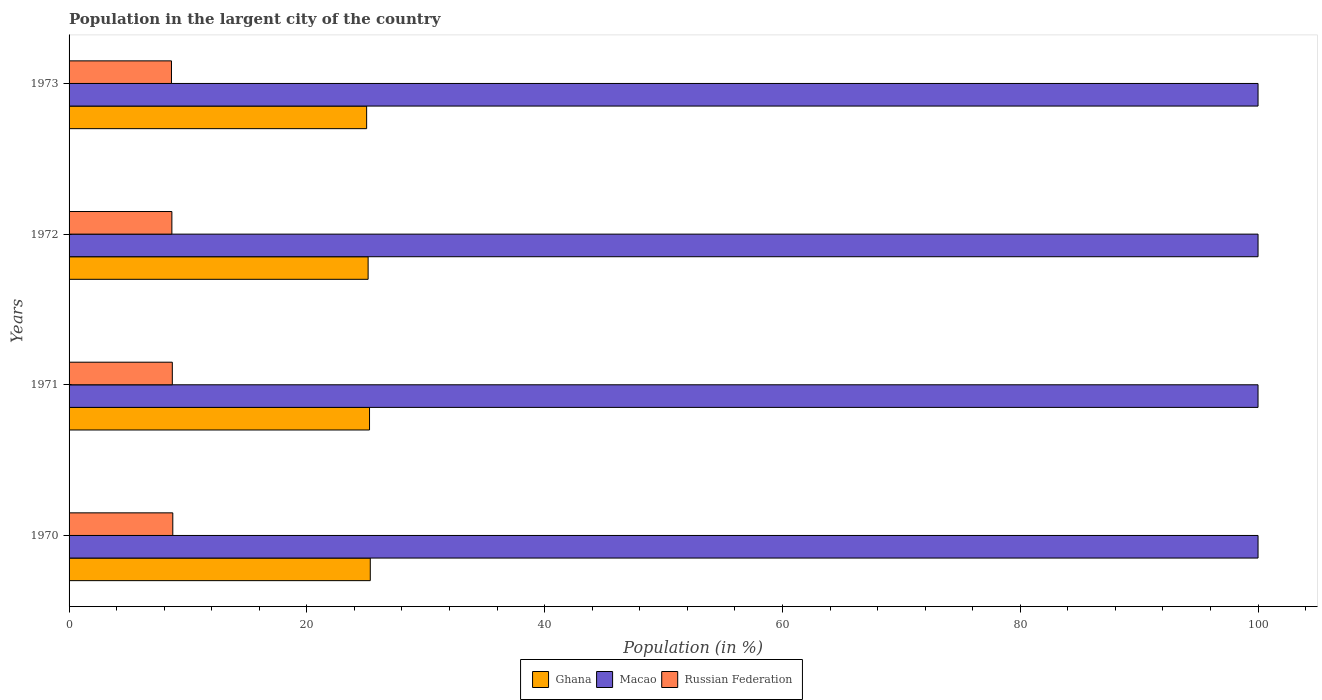How many groups of bars are there?
Give a very brief answer. 4. Are the number of bars per tick equal to the number of legend labels?
Give a very brief answer. Yes. Are the number of bars on each tick of the Y-axis equal?
Your answer should be very brief. Yes. How many bars are there on the 3rd tick from the top?
Your answer should be very brief. 3. How many bars are there on the 3rd tick from the bottom?
Keep it short and to the point. 3. In how many cases, is the number of bars for a given year not equal to the number of legend labels?
Your answer should be compact. 0. What is the percentage of population in the largent city in Russian Federation in 1971?
Your answer should be very brief. 8.68. Across all years, what is the maximum percentage of population in the largent city in Russian Federation?
Provide a succinct answer. 8.72. Across all years, what is the minimum percentage of population in the largent city in Russian Federation?
Your response must be concise. 8.61. In which year was the percentage of population in the largent city in Russian Federation maximum?
Provide a succinct answer. 1970. In which year was the percentage of population in the largent city in Macao minimum?
Make the answer very short. 1971. What is the total percentage of population in the largent city in Macao in the graph?
Your answer should be compact. 400. What is the difference between the percentage of population in the largent city in Macao in 1970 and that in 1973?
Offer a very short reply. 0. What is the difference between the percentage of population in the largent city in Ghana in 1971 and the percentage of population in the largent city in Macao in 1972?
Give a very brief answer. -74.73. What is the average percentage of population in the largent city in Russian Federation per year?
Provide a short and direct response. 8.67. In the year 1971, what is the difference between the percentage of population in the largent city in Ghana and percentage of population in the largent city in Russian Federation?
Give a very brief answer. 16.59. What is the ratio of the percentage of population in the largent city in Ghana in 1971 to that in 1973?
Your response must be concise. 1.01. Is the difference between the percentage of population in the largent city in Ghana in 1970 and 1973 greater than the difference between the percentage of population in the largent city in Russian Federation in 1970 and 1973?
Provide a succinct answer. Yes. What is the difference between the highest and the second highest percentage of population in the largent city in Ghana?
Your answer should be very brief. 0.06. What is the difference between the highest and the lowest percentage of population in the largent city in Macao?
Make the answer very short. 0. In how many years, is the percentage of population in the largent city in Macao greater than the average percentage of population in the largent city in Macao taken over all years?
Provide a succinct answer. 3. What does the 3rd bar from the top in 1970 represents?
Make the answer very short. Ghana. What does the 3rd bar from the bottom in 1973 represents?
Provide a short and direct response. Russian Federation. What is the difference between two consecutive major ticks on the X-axis?
Offer a terse response. 20. Are the values on the major ticks of X-axis written in scientific E-notation?
Your answer should be very brief. No. Does the graph contain any zero values?
Your answer should be very brief. No. Does the graph contain grids?
Your response must be concise. No. How many legend labels are there?
Ensure brevity in your answer.  3. How are the legend labels stacked?
Make the answer very short. Horizontal. What is the title of the graph?
Your answer should be very brief. Population in the largent city of the country. Does "Tajikistan" appear as one of the legend labels in the graph?
Make the answer very short. No. What is the label or title of the X-axis?
Ensure brevity in your answer.  Population (in %). What is the Population (in %) in Ghana in 1970?
Give a very brief answer. 25.33. What is the Population (in %) of Macao in 1970?
Give a very brief answer. 100. What is the Population (in %) of Russian Federation in 1970?
Ensure brevity in your answer.  8.72. What is the Population (in %) of Ghana in 1971?
Provide a succinct answer. 25.27. What is the Population (in %) in Macao in 1971?
Provide a short and direct response. 100. What is the Population (in %) of Russian Federation in 1971?
Make the answer very short. 8.68. What is the Population (in %) of Ghana in 1972?
Give a very brief answer. 25.15. What is the Population (in %) in Russian Federation in 1972?
Offer a very short reply. 8.65. What is the Population (in %) in Ghana in 1973?
Keep it short and to the point. 25.03. What is the Population (in %) in Russian Federation in 1973?
Your answer should be compact. 8.61. Across all years, what is the maximum Population (in %) of Ghana?
Offer a very short reply. 25.33. Across all years, what is the maximum Population (in %) in Macao?
Your answer should be compact. 100. Across all years, what is the maximum Population (in %) in Russian Federation?
Your response must be concise. 8.72. Across all years, what is the minimum Population (in %) in Ghana?
Provide a succinct answer. 25.03. Across all years, what is the minimum Population (in %) in Macao?
Ensure brevity in your answer.  100. Across all years, what is the minimum Population (in %) in Russian Federation?
Your answer should be very brief. 8.61. What is the total Population (in %) in Ghana in the graph?
Provide a succinct answer. 100.78. What is the total Population (in %) of Macao in the graph?
Keep it short and to the point. 400. What is the total Population (in %) in Russian Federation in the graph?
Give a very brief answer. 34.67. What is the difference between the Population (in %) of Ghana in 1970 and that in 1971?
Offer a very short reply. 0.06. What is the difference between the Population (in %) in Macao in 1970 and that in 1971?
Offer a terse response. 0. What is the difference between the Population (in %) in Russian Federation in 1970 and that in 1971?
Ensure brevity in your answer.  0.04. What is the difference between the Population (in %) of Ghana in 1970 and that in 1972?
Offer a terse response. 0.18. What is the difference between the Population (in %) in Macao in 1970 and that in 1972?
Keep it short and to the point. 0. What is the difference between the Population (in %) of Russian Federation in 1970 and that in 1972?
Your answer should be compact. 0.08. What is the difference between the Population (in %) of Ghana in 1970 and that in 1973?
Offer a terse response. 0.31. What is the difference between the Population (in %) of Macao in 1970 and that in 1973?
Your response must be concise. 0. What is the difference between the Population (in %) of Russian Federation in 1970 and that in 1973?
Provide a short and direct response. 0.11. What is the difference between the Population (in %) in Ghana in 1971 and that in 1972?
Offer a very short reply. 0.12. What is the difference between the Population (in %) of Macao in 1971 and that in 1972?
Your answer should be very brief. -0. What is the difference between the Population (in %) of Russian Federation in 1971 and that in 1972?
Offer a terse response. 0.04. What is the difference between the Population (in %) in Ghana in 1971 and that in 1973?
Make the answer very short. 0.24. What is the difference between the Population (in %) of Macao in 1971 and that in 1973?
Your answer should be very brief. -0. What is the difference between the Population (in %) in Russian Federation in 1971 and that in 1973?
Your response must be concise. 0.07. What is the difference between the Population (in %) of Ghana in 1972 and that in 1973?
Provide a succinct answer. 0.12. What is the difference between the Population (in %) in Macao in 1972 and that in 1973?
Give a very brief answer. 0. What is the difference between the Population (in %) in Russian Federation in 1972 and that in 1973?
Provide a short and direct response. 0.03. What is the difference between the Population (in %) of Ghana in 1970 and the Population (in %) of Macao in 1971?
Offer a very short reply. -74.67. What is the difference between the Population (in %) of Ghana in 1970 and the Population (in %) of Russian Federation in 1971?
Your response must be concise. 16.65. What is the difference between the Population (in %) of Macao in 1970 and the Population (in %) of Russian Federation in 1971?
Offer a very short reply. 91.32. What is the difference between the Population (in %) in Ghana in 1970 and the Population (in %) in Macao in 1972?
Your answer should be very brief. -74.67. What is the difference between the Population (in %) of Ghana in 1970 and the Population (in %) of Russian Federation in 1972?
Your answer should be compact. 16.69. What is the difference between the Population (in %) of Macao in 1970 and the Population (in %) of Russian Federation in 1972?
Offer a very short reply. 91.35. What is the difference between the Population (in %) of Ghana in 1970 and the Population (in %) of Macao in 1973?
Provide a short and direct response. -74.67. What is the difference between the Population (in %) of Ghana in 1970 and the Population (in %) of Russian Federation in 1973?
Provide a succinct answer. 16.72. What is the difference between the Population (in %) of Macao in 1970 and the Population (in %) of Russian Federation in 1973?
Keep it short and to the point. 91.39. What is the difference between the Population (in %) in Ghana in 1971 and the Population (in %) in Macao in 1972?
Offer a very short reply. -74.73. What is the difference between the Population (in %) in Ghana in 1971 and the Population (in %) in Russian Federation in 1972?
Keep it short and to the point. 16.62. What is the difference between the Population (in %) of Macao in 1971 and the Population (in %) of Russian Federation in 1972?
Provide a succinct answer. 91.35. What is the difference between the Population (in %) of Ghana in 1971 and the Population (in %) of Macao in 1973?
Offer a very short reply. -74.73. What is the difference between the Population (in %) of Ghana in 1971 and the Population (in %) of Russian Federation in 1973?
Ensure brevity in your answer.  16.66. What is the difference between the Population (in %) of Macao in 1971 and the Population (in %) of Russian Federation in 1973?
Make the answer very short. 91.39. What is the difference between the Population (in %) of Ghana in 1972 and the Population (in %) of Macao in 1973?
Offer a terse response. -74.85. What is the difference between the Population (in %) in Ghana in 1972 and the Population (in %) in Russian Federation in 1973?
Make the answer very short. 16.54. What is the difference between the Population (in %) in Macao in 1972 and the Population (in %) in Russian Federation in 1973?
Offer a very short reply. 91.39. What is the average Population (in %) of Ghana per year?
Make the answer very short. 25.2. What is the average Population (in %) in Macao per year?
Offer a very short reply. 100. What is the average Population (in %) in Russian Federation per year?
Offer a terse response. 8.67. In the year 1970, what is the difference between the Population (in %) in Ghana and Population (in %) in Macao?
Offer a very short reply. -74.67. In the year 1970, what is the difference between the Population (in %) in Ghana and Population (in %) in Russian Federation?
Ensure brevity in your answer.  16.61. In the year 1970, what is the difference between the Population (in %) in Macao and Population (in %) in Russian Federation?
Offer a terse response. 91.28. In the year 1971, what is the difference between the Population (in %) in Ghana and Population (in %) in Macao?
Give a very brief answer. -74.73. In the year 1971, what is the difference between the Population (in %) of Ghana and Population (in %) of Russian Federation?
Your answer should be very brief. 16.59. In the year 1971, what is the difference between the Population (in %) in Macao and Population (in %) in Russian Federation?
Your response must be concise. 91.32. In the year 1972, what is the difference between the Population (in %) in Ghana and Population (in %) in Macao?
Ensure brevity in your answer.  -74.85. In the year 1972, what is the difference between the Population (in %) of Ghana and Population (in %) of Russian Federation?
Make the answer very short. 16.51. In the year 1972, what is the difference between the Population (in %) of Macao and Population (in %) of Russian Federation?
Give a very brief answer. 91.35. In the year 1973, what is the difference between the Population (in %) in Ghana and Population (in %) in Macao?
Your answer should be compact. -74.97. In the year 1973, what is the difference between the Population (in %) in Ghana and Population (in %) in Russian Federation?
Provide a short and direct response. 16.42. In the year 1973, what is the difference between the Population (in %) in Macao and Population (in %) in Russian Federation?
Keep it short and to the point. 91.39. What is the ratio of the Population (in %) in Macao in 1970 to that in 1971?
Provide a succinct answer. 1. What is the ratio of the Population (in %) in Macao in 1970 to that in 1972?
Give a very brief answer. 1. What is the ratio of the Population (in %) in Russian Federation in 1970 to that in 1972?
Give a very brief answer. 1.01. What is the ratio of the Population (in %) of Ghana in 1970 to that in 1973?
Provide a succinct answer. 1.01. What is the ratio of the Population (in %) of Russian Federation in 1970 to that in 1973?
Keep it short and to the point. 1.01. What is the ratio of the Population (in %) in Ghana in 1971 to that in 1972?
Make the answer very short. 1. What is the ratio of the Population (in %) in Ghana in 1971 to that in 1973?
Ensure brevity in your answer.  1.01. What is the ratio of the Population (in %) of Macao in 1971 to that in 1973?
Provide a succinct answer. 1. What is the ratio of the Population (in %) of Russian Federation in 1971 to that in 1973?
Provide a succinct answer. 1.01. What is the ratio of the Population (in %) in Macao in 1972 to that in 1973?
Offer a terse response. 1. What is the difference between the highest and the second highest Population (in %) of Ghana?
Your answer should be very brief. 0.06. What is the difference between the highest and the second highest Population (in %) of Russian Federation?
Your answer should be compact. 0.04. What is the difference between the highest and the lowest Population (in %) of Ghana?
Keep it short and to the point. 0.31. What is the difference between the highest and the lowest Population (in %) of Russian Federation?
Provide a succinct answer. 0.11. 